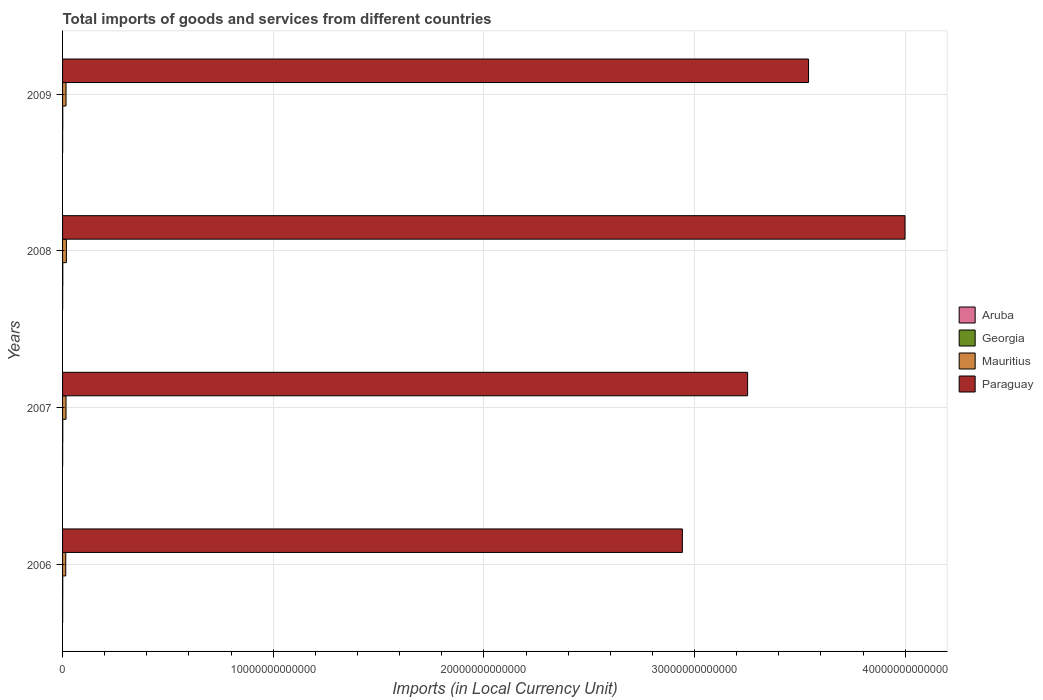How many different coloured bars are there?
Make the answer very short. 4. How many bars are there on the 4th tick from the top?
Offer a terse response. 4. How many bars are there on the 2nd tick from the bottom?
Make the answer very short. 4. What is the label of the 4th group of bars from the top?
Make the answer very short. 2006. In how many cases, is the number of bars for a given year not equal to the number of legend labels?
Provide a short and direct response. 0. What is the Amount of goods and services imports in Mauritius in 2006?
Provide a short and direct response. 1.51e+11. Across all years, what is the maximum Amount of goods and services imports in Mauritius?
Ensure brevity in your answer.  1.81e+11. Across all years, what is the minimum Amount of goods and services imports in Mauritius?
Offer a very short reply. 1.51e+11. In which year was the Amount of goods and services imports in Aruba minimum?
Offer a very short reply. 2006. What is the total Amount of goods and services imports in Mauritius in the graph?
Your response must be concise. 6.61e+11. What is the difference between the Amount of goods and services imports in Paraguay in 2007 and that in 2008?
Make the answer very short. -7.47e+12. What is the difference between the Amount of goods and services imports in Paraguay in 2009 and the Amount of goods and services imports in Mauritius in 2007?
Keep it short and to the point. 3.52e+13. What is the average Amount of goods and services imports in Paraguay per year?
Your answer should be very brief. 3.43e+13. In the year 2009, what is the difference between the Amount of goods and services imports in Georgia and Amount of goods and services imports in Aruba?
Keep it short and to the point. 5.39e+09. In how many years, is the Amount of goods and services imports in Paraguay greater than 34000000000000 LCU?
Give a very brief answer. 2. What is the ratio of the Amount of goods and services imports in Aruba in 2006 to that in 2008?
Your answer should be compact. 0.9. Is the Amount of goods and services imports in Aruba in 2007 less than that in 2008?
Provide a succinct answer. Yes. Is the difference between the Amount of goods and services imports in Georgia in 2007 and 2008 greater than the difference between the Amount of goods and services imports in Aruba in 2007 and 2008?
Your answer should be compact. No. What is the difference between the highest and the second highest Amount of goods and services imports in Mauritius?
Make the answer very short. 1.67e+1. What is the difference between the highest and the lowest Amount of goods and services imports in Paraguay?
Provide a succinct answer. 1.06e+13. Is the sum of the Amount of goods and services imports in Paraguay in 2006 and 2007 greater than the maximum Amount of goods and services imports in Aruba across all years?
Provide a succinct answer. Yes. Is it the case that in every year, the sum of the Amount of goods and services imports in Paraguay and Amount of goods and services imports in Aruba is greater than the sum of Amount of goods and services imports in Mauritius and Amount of goods and services imports in Georgia?
Make the answer very short. Yes. What does the 1st bar from the top in 2006 represents?
Offer a very short reply. Paraguay. What does the 1st bar from the bottom in 2008 represents?
Provide a succinct answer. Aruba. Are all the bars in the graph horizontal?
Your answer should be very brief. Yes. What is the difference between two consecutive major ticks on the X-axis?
Offer a terse response. 1.00e+13. Are the values on the major ticks of X-axis written in scientific E-notation?
Offer a terse response. No. Does the graph contain any zero values?
Offer a terse response. No. How many legend labels are there?
Give a very brief answer. 4. What is the title of the graph?
Offer a terse response. Total imports of goods and services from different countries. Does "Somalia" appear as one of the legend labels in the graph?
Your answer should be compact. No. What is the label or title of the X-axis?
Make the answer very short. Imports (in Local Currency Unit). What is the Imports (in Local Currency Unit) in Aruba in 2006?
Provide a succinct answer. 3.38e+09. What is the Imports (in Local Currency Unit) in Georgia in 2006?
Ensure brevity in your answer.  7.86e+09. What is the Imports (in Local Currency Unit) of Mauritius in 2006?
Your response must be concise. 1.51e+11. What is the Imports (in Local Currency Unit) of Paraguay in 2006?
Offer a very short reply. 2.94e+13. What is the Imports (in Local Currency Unit) in Aruba in 2007?
Offer a very short reply. 3.59e+09. What is the Imports (in Local Currency Unit) of Georgia in 2007?
Make the answer very short. 9.85e+09. What is the Imports (in Local Currency Unit) of Mauritius in 2007?
Your answer should be compact. 1.64e+11. What is the Imports (in Local Currency Unit) of Paraguay in 2007?
Give a very brief answer. 3.25e+13. What is the Imports (in Local Currency Unit) in Aruba in 2008?
Offer a very short reply. 3.74e+09. What is the Imports (in Local Currency Unit) of Georgia in 2008?
Ensure brevity in your answer.  1.11e+1. What is the Imports (in Local Currency Unit) of Mauritius in 2008?
Keep it short and to the point. 1.81e+11. What is the Imports (in Local Currency Unit) of Paraguay in 2008?
Offer a very short reply. 4.00e+13. What is the Imports (in Local Currency Unit) in Aruba in 2009?
Keep it short and to the point. 3.41e+09. What is the Imports (in Local Currency Unit) in Georgia in 2009?
Your answer should be compact. 8.80e+09. What is the Imports (in Local Currency Unit) of Mauritius in 2009?
Offer a very short reply. 1.65e+11. What is the Imports (in Local Currency Unit) in Paraguay in 2009?
Make the answer very short. 3.54e+13. Across all years, what is the maximum Imports (in Local Currency Unit) in Aruba?
Your response must be concise. 3.74e+09. Across all years, what is the maximum Imports (in Local Currency Unit) of Georgia?
Your answer should be compact. 1.11e+1. Across all years, what is the maximum Imports (in Local Currency Unit) of Mauritius?
Offer a very short reply. 1.81e+11. Across all years, what is the maximum Imports (in Local Currency Unit) of Paraguay?
Your answer should be very brief. 4.00e+13. Across all years, what is the minimum Imports (in Local Currency Unit) of Aruba?
Provide a succinct answer. 3.38e+09. Across all years, what is the minimum Imports (in Local Currency Unit) in Georgia?
Offer a terse response. 7.86e+09. Across all years, what is the minimum Imports (in Local Currency Unit) of Mauritius?
Provide a short and direct response. 1.51e+11. Across all years, what is the minimum Imports (in Local Currency Unit) in Paraguay?
Your response must be concise. 2.94e+13. What is the total Imports (in Local Currency Unit) in Aruba in the graph?
Provide a succinct answer. 1.41e+1. What is the total Imports (in Local Currency Unit) in Georgia in the graph?
Give a very brief answer. 3.77e+1. What is the total Imports (in Local Currency Unit) in Mauritius in the graph?
Give a very brief answer. 6.61e+11. What is the total Imports (in Local Currency Unit) in Paraguay in the graph?
Make the answer very short. 1.37e+14. What is the difference between the Imports (in Local Currency Unit) of Aruba in 2006 and that in 2007?
Give a very brief answer. -2.11e+08. What is the difference between the Imports (in Local Currency Unit) in Georgia in 2006 and that in 2007?
Ensure brevity in your answer.  -1.99e+09. What is the difference between the Imports (in Local Currency Unit) in Mauritius in 2006 and that in 2007?
Keep it short and to the point. -1.25e+1. What is the difference between the Imports (in Local Currency Unit) in Paraguay in 2006 and that in 2007?
Offer a terse response. -3.10e+12. What is the difference between the Imports (in Local Currency Unit) in Aruba in 2006 and that in 2008?
Your response must be concise. -3.65e+08. What is the difference between the Imports (in Local Currency Unit) in Georgia in 2006 and that in 2008?
Offer a very short reply. -3.28e+09. What is the difference between the Imports (in Local Currency Unit) of Mauritius in 2006 and that in 2008?
Keep it short and to the point. -2.99e+1. What is the difference between the Imports (in Local Currency Unit) of Paraguay in 2006 and that in 2008?
Your response must be concise. -1.06e+13. What is the difference between the Imports (in Local Currency Unit) of Aruba in 2006 and that in 2009?
Your answer should be compact. -3.22e+07. What is the difference between the Imports (in Local Currency Unit) of Georgia in 2006 and that in 2009?
Your answer should be compact. -9.39e+08. What is the difference between the Imports (in Local Currency Unit) of Mauritius in 2006 and that in 2009?
Your answer should be compact. -1.32e+1. What is the difference between the Imports (in Local Currency Unit) of Paraguay in 2006 and that in 2009?
Make the answer very short. -5.99e+12. What is the difference between the Imports (in Local Currency Unit) in Aruba in 2007 and that in 2008?
Ensure brevity in your answer.  -1.54e+08. What is the difference between the Imports (in Local Currency Unit) of Georgia in 2007 and that in 2008?
Provide a succinct answer. -1.29e+09. What is the difference between the Imports (in Local Currency Unit) in Mauritius in 2007 and that in 2008?
Provide a short and direct response. -1.74e+1. What is the difference between the Imports (in Local Currency Unit) of Paraguay in 2007 and that in 2008?
Give a very brief answer. -7.47e+12. What is the difference between the Imports (in Local Currency Unit) in Aruba in 2007 and that in 2009?
Your answer should be compact. 1.79e+08. What is the difference between the Imports (in Local Currency Unit) in Georgia in 2007 and that in 2009?
Keep it short and to the point. 1.05e+09. What is the difference between the Imports (in Local Currency Unit) of Mauritius in 2007 and that in 2009?
Provide a succinct answer. -7.59e+08. What is the difference between the Imports (in Local Currency Unit) in Paraguay in 2007 and that in 2009?
Make the answer very short. -2.89e+12. What is the difference between the Imports (in Local Currency Unit) in Aruba in 2008 and that in 2009?
Provide a short and direct response. 3.33e+08. What is the difference between the Imports (in Local Currency Unit) of Georgia in 2008 and that in 2009?
Provide a succinct answer. 2.34e+09. What is the difference between the Imports (in Local Currency Unit) in Mauritius in 2008 and that in 2009?
Keep it short and to the point. 1.67e+1. What is the difference between the Imports (in Local Currency Unit) of Paraguay in 2008 and that in 2009?
Keep it short and to the point. 4.58e+12. What is the difference between the Imports (in Local Currency Unit) in Aruba in 2006 and the Imports (in Local Currency Unit) in Georgia in 2007?
Your answer should be compact. -6.47e+09. What is the difference between the Imports (in Local Currency Unit) in Aruba in 2006 and the Imports (in Local Currency Unit) in Mauritius in 2007?
Your answer should be very brief. -1.61e+11. What is the difference between the Imports (in Local Currency Unit) in Aruba in 2006 and the Imports (in Local Currency Unit) in Paraguay in 2007?
Provide a short and direct response. -3.25e+13. What is the difference between the Imports (in Local Currency Unit) in Georgia in 2006 and the Imports (in Local Currency Unit) in Mauritius in 2007?
Your response must be concise. -1.56e+11. What is the difference between the Imports (in Local Currency Unit) in Georgia in 2006 and the Imports (in Local Currency Unit) in Paraguay in 2007?
Provide a short and direct response. -3.25e+13. What is the difference between the Imports (in Local Currency Unit) in Mauritius in 2006 and the Imports (in Local Currency Unit) in Paraguay in 2007?
Your answer should be very brief. -3.24e+13. What is the difference between the Imports (in Local Currency Unit) of Aruba in 2006 and the Imports (in Local Currency Unit) of Georgia in 2008?
Offer a very short reply. -7.76e+09. What is the difference between the Imports (in Local Currency Unit) in Aruba in 2006 and the Imports (in Local Currency Unit) in Mauritius in 2008?
Provide a succinct answer. -1.78e+11. What is the difference between the Imports (in Local Currency Unit) of Aruba in 2006 and the Imports (in Local Currency Unit) of Paraguay in 2008?
Offer a terse response. -4.00e+13. What is the difference between the Imports (in Local Currency Unit) of Georgia in 2006 and the Imports (in Local Currency Unit) of Mauritius in 2008?
Your answer should be compact. -1.73e+11. What is the difference between the Imports (in Local Currency Unit) in Georgia in 2006 and the Imports (in Local Currency Unit) in Paraguay in 2008?
Offer a terse response. -4.00e+13. What is the difference between the Imports (in Local Currency Unit) of Mauritius in 2006 and the Imports (in Local Currency Unit) of Paraguay in 2008?
Offer a terse response. -3.98e+13. What is the difference between the Imports (in Local Currency Unit) of Aruba in 2006 and the Imports (in Local Currency Unit) of Georgia in 2009?
Provide a succinct answer. -5.42e+09. What is the difference between the Imports (in Local Currency Unit) of Aruba in 2006 and the Imports (in Local Currency Unit) of Mauritius in 2009?
Your response must be concise. -1.61e+11. What is the difference between the Imports (in Local Currency Unit) of Aruba in 2006 and the Imports (in Local Currency Unit) of Paraguay in 2009?
Your answer should be very brief. -3.54e+13. What is the difference between the Imports (in Local Currency Unit) in Georgia in 2006 and the Imports (in Local Currency Unit) in Mauritius in 2009?
Make the answer very short. -1.57e+11. What is the difference between the Imports (in Local Currency Unit) in Georgia in 2006 and the Imports (in Local Currency Unit) in Paraguay in 2009?
Provide a short and direct response. -3.54e+13. What is the difference between the Imports (in Local Currency Unit) in Mauritius in 2006 and the Imports (in Local Currency Unit) in Paraguay in 2009?
Provide a succinct answer. -3.53e+13. What is the difference between the Imports (in Local Currency Unit) of Aruba in 2007 and the Imports (in Local Currency Unit) of Georgia in 2008?
Your response must be concise. -7.55e+09. What is the difference between the Imports (in Local Currency Unit) in Aruba in 2007 and the Imports (in Local Currency Unit) in Mauritius in 2008?
Give a very brief answer. -1.78e+11. What is the difference between the Imports (in Local Currency Unit) of Aruba in 2007 and the Imports (in Local Currency Unit) of Paraguay in 2008?
Keep it short and to the point. -4.00e+13. What is the difference between the Imports (in Local Currency Unit) of Georgia in 2007 and the Imports (in Local Currency Unit) of Mauritius in 2008?
Your answer should be very brief. -1.71e+11. What is the difference between the Imports (in Local Currency Unit) in Georgia in 2007 and the Imports (in Local Currency Unit) in Paraguay in 2008?
Provide a succinct answer. -4.00e+13. What is the difference between the Imports (in Local Currency Unit) in Mauritius in 2007 and the Imports (in Local Currency Unit) in Paraguay in 2008?
Give a very brief answer. -3.98e+13. What is the difference between the Imports (in Local Currency Unit) of Aruba in 2007 and the Imports (in Local Currency Unit) of Georgia in 2009?
Make the answer very short. -5.21e+09. What is the difference between the Imports (in Local Currency Unit) in Aruba in 2007 and the Imports (in Local Currency Unit) in Mauritius in 2009?
Provide a succinct answer. -1.61e+11. What is the difference between the Imports (in Local Currency Unit) in Aruba in 2007 and the Imports (in Local Currency Unit) in Paraguay in 2009?
Give a very brief answer. -3.54e+13. What is the difference between the Imports (in Local Currency Unit) of Georgia in 2007 and the Imports (in Local Currency Unit) of Mauritius in 2009?
Offer a terse response. -1.55e+11. What is the difference between the Imports (in Local Currency Unit) in Georgia in 2007 and the Imports (in Local Currency Unit) in Paraguay in 2009?
Give a very brief answer. -3.54e+13. What is the difference between the Imports (in Local Currency Unit) of Mauritius in 2007 and the Imports (in Local Currency Unit) of Paraguay in 2009?
Ensure brevity in your answer.  -3.52e+13. What is the difference between the Imports (in Local Currency Unit) of Aruba in 2008 and the Imports (in Local Currency Unit) of Georgia in 2009?
Ensure brevity in your answer.  -5.06e+09. What is the difference between the Imports (in Local Currency Unit) of Aruba in 2008 and the Imports (in Local Currency Unit) of Mauritius in 2009?
Provide a succinct answer. -1.61e+11. What is the difference between the Imports (in Local Currency Unit) of Aruba in 2008 and the Imports (in Local Currency Unit) of Paraguay in 2009?
Make the answer very short. -3.54e+13. What is the difference between the Imports (in Local Currency Unit) of Georgia in 2008 and the Imports (in Local Currency Unit) of Mauritius in 2009?
Give a very brief answer. -1.54e+11. What is the difference between the Imports (in Local Currency Unit) in Georgia in 2008 and the Imports (in Local Currency Unit) in Paraguay in 2009?
Ensure brevity in your answer.  -3.54e+13. What is the difference between the Imports (in Local Currency Unit) of Mauritius in 2008 and the Imports (in Local Currency Unit) of Paraguay in 2009?
Provide a short and direct response. -3.52e+13. What is the average Imports (in Local Currency Unit) in Aruba per year?
Your answer should be compact. 3.53e+09. What is the average Imports (in Local Currency Unit) in Georgia per year?
Your response must be concise. 9.41e+09. What is the average Imports (in Local Currency Unit) in Mauritius per year?
Your answer should be compact. 1.65e+11. What is the average Imports (in Local Currency Unit) in Paraguay per year?
Offer a terse response. 3.43e+13. In the year 2006, what is the difference between the Imports (in Local Currency Unit) of Aruba and Imports (in Local Currency Unit) of Georgia?
Offer a very short reply. -4.48e+09. In the year 2006, what is the difference between the Imports (in Local Currency Unit) in Aruba and Imports (in Local Currency Unit) in Mauritius?
Give a very brief answer. -1.48e+11. In the year 2006, what is the difference between the Imports (in Local Currency Unit) in Aruba and Imports (in Local Currency Unit) in Paraguay?
Offer a very short reply. -2.94e+13. In the year 2006, what is the difference between the Imports (in Local Currency Unit) in Georgia and Imports (in Local Currency Unit) in Mauritius?
Your response must be concise. -1.44e+11. In the year 2006, what is the difference between the Imports (in Local Currency Unit) of Georgia and Imports (in Local Currency Unit) of Paraguay?
Ensure brevity in your answer.  -2.94e+13. In the year 2006, what is the difference between the Imports (in Local Currency Unit) of Mauritius and Imports (in Local Currency Unit) of Paraguay?
Offer a very short reply. -2.93e+13. In the year 2007, what is the difference between the Imports (in Local Currency Unit) of Aruba and Imports (in Local Currency Unit) of Georgia?
Your response must be concise. -6.26e+09. In the year 2007, what is the difference between the Imports (in Local Currency Unit) of Aruba and Imports (in Local Currency Unit) of Mauritius?
Keep it short and to the point. -1.60e+11. In the year 2007, what is the difference between the Imports (in Local Currency Unit) of Aruba and Imports (in Local Currency Unit) of Paraguay?
Make the answer very short. -3.25e+13. In the year 2007, what is the difference between the Imports (in Local Currency Unit) in Georgia and Imports (in Local Currency Unit) in Mauritius?
Provide a succinct answer. -1.54e+11. In the year 2007, what is the difference between the Imports (in Local Currency Unit) of Georgia and Imports (in Local Currency Unit) of Paraguay?
Ensure brevity in your answer.  -3.25e+13. In the year 2007, what is the difference between the Imports (in Local Currency Unit) of Mauritius and Imports (in Local Currency Unit) of Paraguay?
Your answer should be very brief. -3.24e+13. In the year 2008, what is the difference between the Imports (in Local Currency Unit) of Aruba and Imports (in Local Currency Unit) of Georgia?
Make the answer very short. -7.40e+09. In the year 2008, what is the difference between the Imports (in Local Currency Unit) in Aruba and Imports (in Local Currency Unit) in Mauritius?
Offer a terse response. -1.78e+11. In the year 2008, what is the difference between the Imports (in Local Currency Unit) in Aruba and Imports (in Local Currency Unit) in Paraguay?
Offer a very short reply. -4.00e+13. In the year 2008, what is the difference between the Imports (in Local Currency Unit) in Georgia and Imports (in Local Currency Unit) in Mauritius?
Offer a terse response. -1.70e+11. In the year 2008, what is the difference between the Imports (in Local Currency Unit) in Georgia and Imports (in Local Currency Unit) in Paraguay?
Provide a short and direct response. -4.00e+13. In the year 2008, what is the difference between the Imports (in Local Currency Unit) in Mauritius and Imports (in Local Currency Unit) in Paraguay?
Your answer should be very brief. -3.98e+13. In the year 2009, what is the difference between the Imports (in Local Currency Unit) in Aruba and Imports (in Local Currency Unit) in Georgia?
Make the answer very short. -5.39e+09. In the year 2009, what is the difference between the Imports (in Local Currency Unit) in Aruba and Imports (in Local Currency Unit) in Mauritius?
Keep it short and to the point. -1.61e+11. In the year 2009, what is the difference between the Imports (in Local Currency Unit) in Aruba and Imports (in Local Currency Unit) in Paraguay?
Your answer should be very brief. -3.54e+13. In the year 2009, what is the difference between the Imports (in Local Currency Unit) in Georgia and Imports (in Local Currency Unit) in Mauritius?
Your answer should be compact. -1.56e+11. In the year 2009, what is the difference between the Imports (in Local Currency Unit) of Georgia and Imports (in Local Currency Unit) of Paraguay?
Provide a succinct answer. -3.54e+13. In the year 2009, what is the difference between the Imports (in Local Currency Unit) of Mauritius and Imports (in Local Currency Unit) of Paraguay?
Offer a terse response. -3.52e+13. What is the ratio of the Imports (in Local Currency Unit) in Aruba in 2006 to that in 2007?
Ensure brevity in your answer.  0.94. What is the ratio of the Imports (in Local Currency Unit) in Georgia in 2006 to that in 2007?
Make the answer very short. 0.8. What is the ratio of the Imports (in Local Currency Unit) in Mauritius in 2006 to that in 2007?
Ensure brevity in your answer.  0.92. What is the ratio of the Imports (in Local Currency Unit) of Paraguay in 2006 to that in 2007?
Offer a terse response. 0.9. What is the ratio of the Imports (in Local Currency Unit) of Aruba in 2006 to that in 2008?
Provide a succinct answer. 0.9. What is the ratio of the Imports (in Local Currency Unit) in Georgia in 2006 to that in 2008?
Your answer should be very brief. 0.71. What is the ratio of the Imports (in Local Currency Unit) of Mauritius in 2006 to that in 2008?
Provide a short and direct response. 0.84. What is the ratio of the Imports (in Local Currency Unit) of Paraguay in 2006 to that in 2008?
Your answer should be very brief. 0.74. What is the ratio of the Imports (in Local Currency Unit) in Aruba in 2006 to that in 2009?
Ensure brevity in your answer.  0.99. What is the ratio of the Imports (in Local Currency Unit) of Georgia in 2006 to that in 2009?
Give a very brief answer. 0.89. What is the ratio of the Imports (in Local Currency Unit) of Mauritius in 2006 to that in 2009?
Keep it short and to the point. 0.92. What is the ratio of the Imports (in Local Currency Unit) of Paraguay in 2006 to that in 2009?
Ensure brevity in your answer.  0.83. What is the ratio of the Imports (in Local Currency Unit) of Aruba in 2007 to that in 2008?
Make the answer very short. 0.96. What is the ratio of the Imports (in Local Currency Unit) in Georgia in 2007 to that in 2008?
Provide a short and direct response. 0.88. What is the ratio of the Imports (in Local Currency Unit) of Mauritius in 2007 to that in 2008?
Make the answer very short. 0.9. What is the ratio of the Imports (in Local Currency Unit) in Paraguay in 2007 to that in 2008?
Provide a short and direct response. 0.81. What is the ratio of the Imports (in Local Currency Unit) of Aruba in 2007 to that in 2009?
Ensure brevity in your answer.  1.05. What is the ratio of the Imports (in Local Currency Unit) in Georgia in 2007 to that in 2009?
Your response must be concise. 1.12. What is the ratio of the Imports (in Local Currency Unit) of Mauritius in 2007 to that in 2009?
Provide a short and direct response. 1. What is the ratio of the Imports (in Local Currency Unit) of Paraguay in 2007 to that in 2009?
Make the answer very short. 0.92. What is the ratio of the Imports (in Local Currency Unit) of Aruba in 2008 to that in 2009?
Offer a terse response. 1.1. What is the ratio of the Imports (in Local Currency Unit) of Georgia in 2008 to that in 2009?
Provide a succinct answer. 1.27. What is the ratio of the Imports (in Local Currency Unit) of Mauritius in 2008 to that in 2009?
Keep it short and to the point. 1.1. What is the ratio of the Imports (in Local Currency Unit) of Paraguay in 2008 to that in 2009?
Make the answer very short. 1.13. What is the difference between the highest and the second highest Imports (in Local Currency Unit) of Aruba?
Your response must be concise. 1.54e+08. What is the difference between the highest and the second highest Imports (in Local Currency Unit) of Georgia?
Ensure brevity in your answer.  1.29e+09. What is the difference between the highest and the second highest Imports (in Local Currency Unit) of Mauritius?
Offer a terse response. 1.67e+1. What is the difference between the highest and the second highest Imports (in Local Currency Unit) of Paraguay?
Provide a succinct answer. 4.58e+12. What is the difference between the highest and the lowest Imports (in Local Currency Unit) of Aruba?
Offer a very short reply. 3.65e+08. What is the difference between the highest and the lowest Imports (in Local Currency Unit) of Georgia?
Make the answer very short. 3.28e+09. What is the difference between the highest and the lowest Imports (in Local Currency Unit) of Mauritius?
Offer a terse response. 2.99e+1. What is the difference between the highest and the lowest Imports (in Local Currency Unit) in Paraguay?
Offer a terse response. 1.06e+13. 